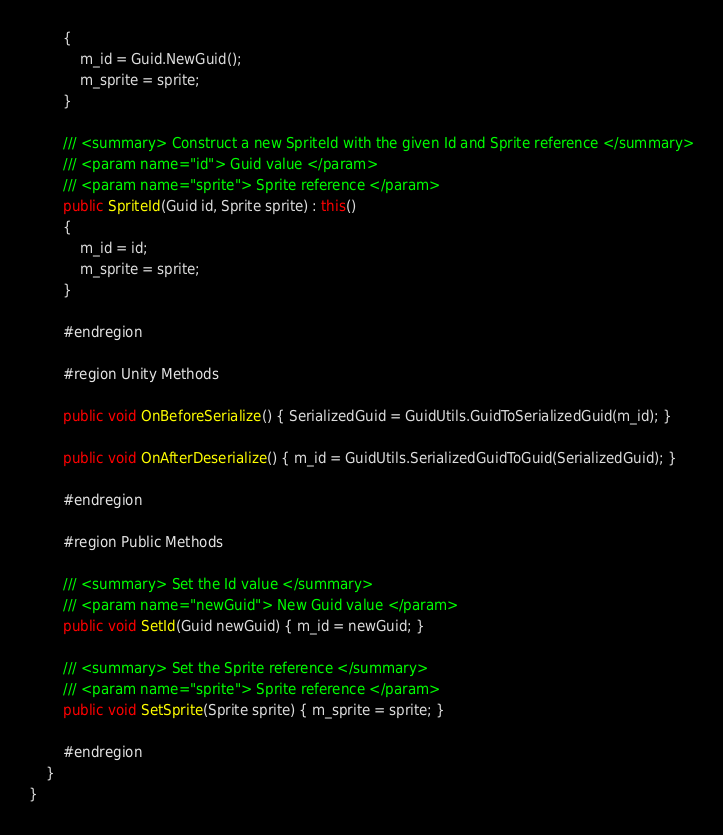<code> <loc_0><loc_0><loc_500><loc_500><_C#_>        {
            m_id = Guid.NewGuid();
            m_sprite = sprite;
        }

        /// <summary> Construct a new SpriteId with the given Id and Sprite reference </summary>
        /// <param name="id"> Guid value </param>
        /// <param name="sprite"> Sprite reference </param>
        public SpriteId(Guid id, Sprite sprite) : this()
        {
            m_id = id;
            m_sprite = sprite;
        }

        #endregion

        #region Unity Methods

        public void OnBeforeSerialize() { SerializedGuid = GuidUtils.GuidToSerializedGuid(m_id); }

        public void OnAfterDeserialize() { m_id = GuidUtils.SerializedGuidToGuid(SerializedGuid); }

        #endregion

        #region Public Methods

        /// <summary> Set the Id value </summary>
        /// <param name="newGuid"> New Guid value </param>
        public void SetId(Guid newGuid) { m_id = newGuid; }

        /// <summary> Set the Sprite reference </summary>
        /// <param name="sprite"> Sprite reference </param>
        public void SetSprite(Sprite sprite) { m_sprite = sprite; }

        #endregion
    }
}</code> 